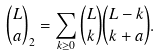<formula> <loc_0><loc_0><loc_500><loc_500>\binom { L } { a } _ { 2 } = \sum _ { k \geq 0 } \binom { L } { k } \binom { L - k } { k + a } .</formula> 